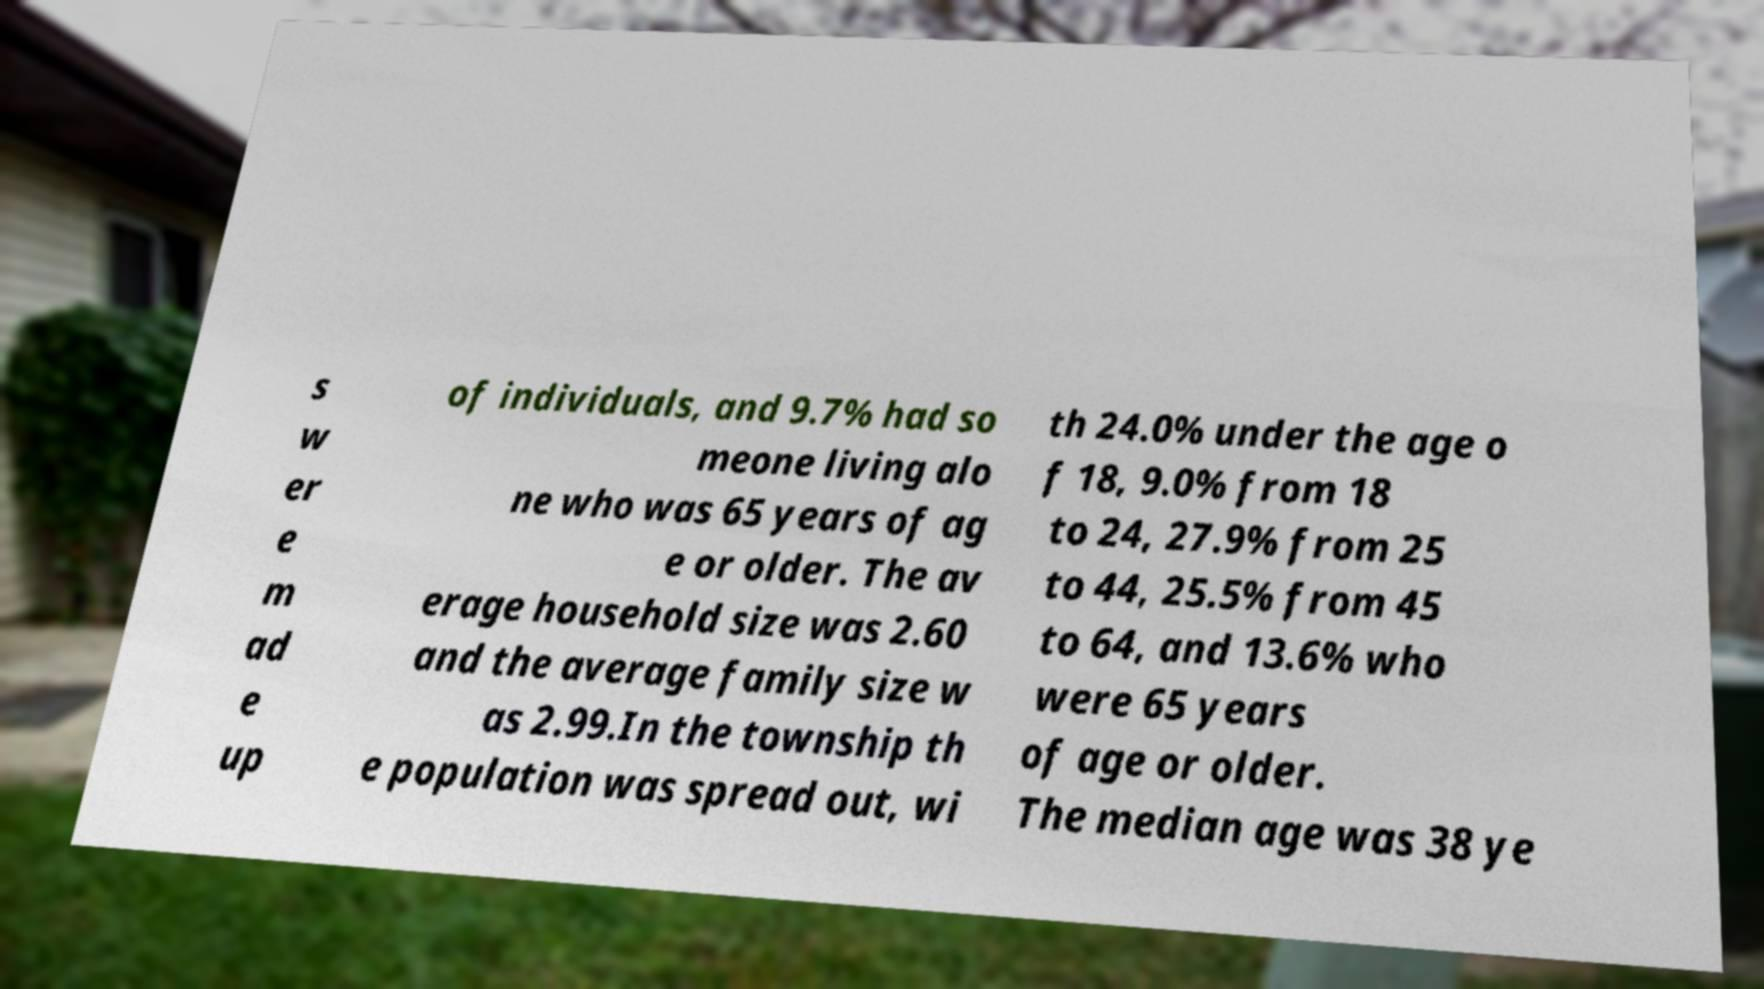Please identify and transcribe the text found in this image. s w er e m ad e up of individuals, and 9.7% had so meone living alo ne who was 65 years of ag e or older. The av erage household size was 2.60 and the average family size w as 2.99.In the township th e population was spread out, wi th 24.0% under the age o f 18, 9.0% from 18 to 24, 27.9% from 25 to 44, 25.5% from 45 to 64, and 13.6% who were 65 years of age or older. The median age was 38 ye 